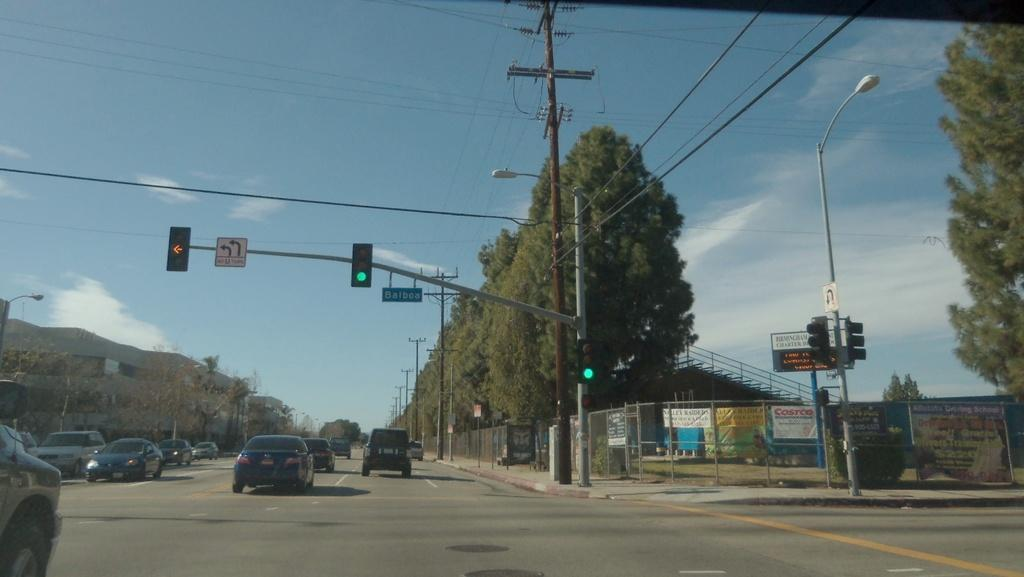<image>
Write a terse but informative summary of the picture. A green traffic light crossing the Balboa street intersection. 